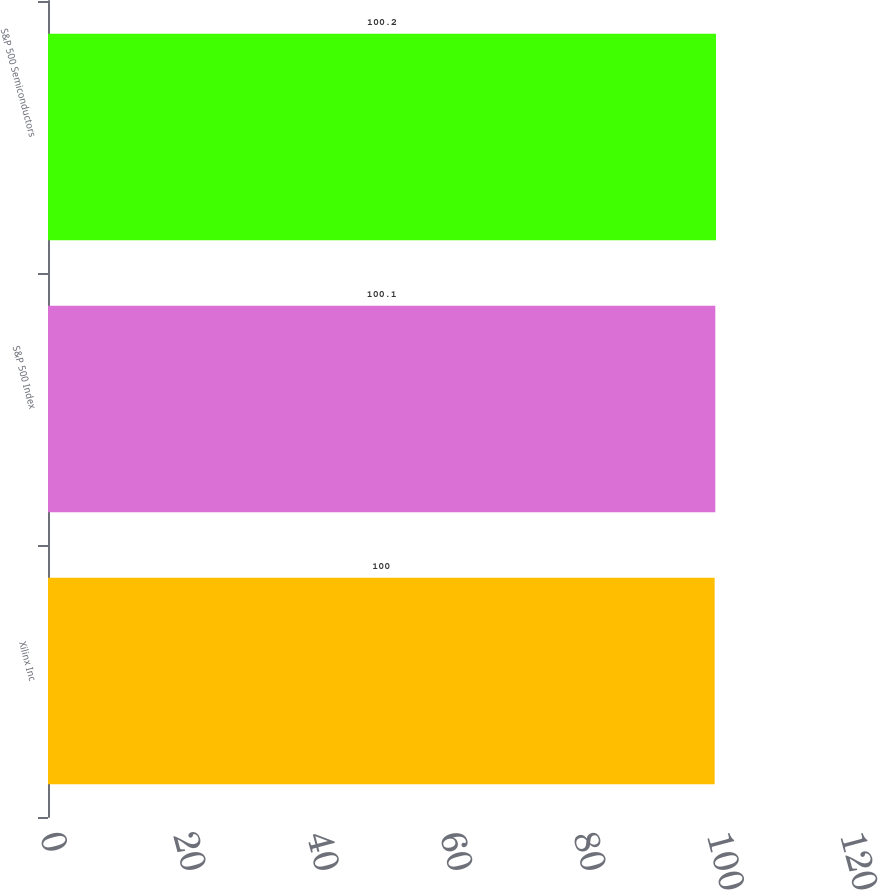Convert chart. <chart><loc_0><loc_0><loc_500><loc_500><bar_chart><fcel>Xilinx Inc<fcel>S&P 500 Index<fcel>S&P 500 Semiconductors<nl><fcel>100<fcel>100.1<fcel>100.2<nl></chart> 